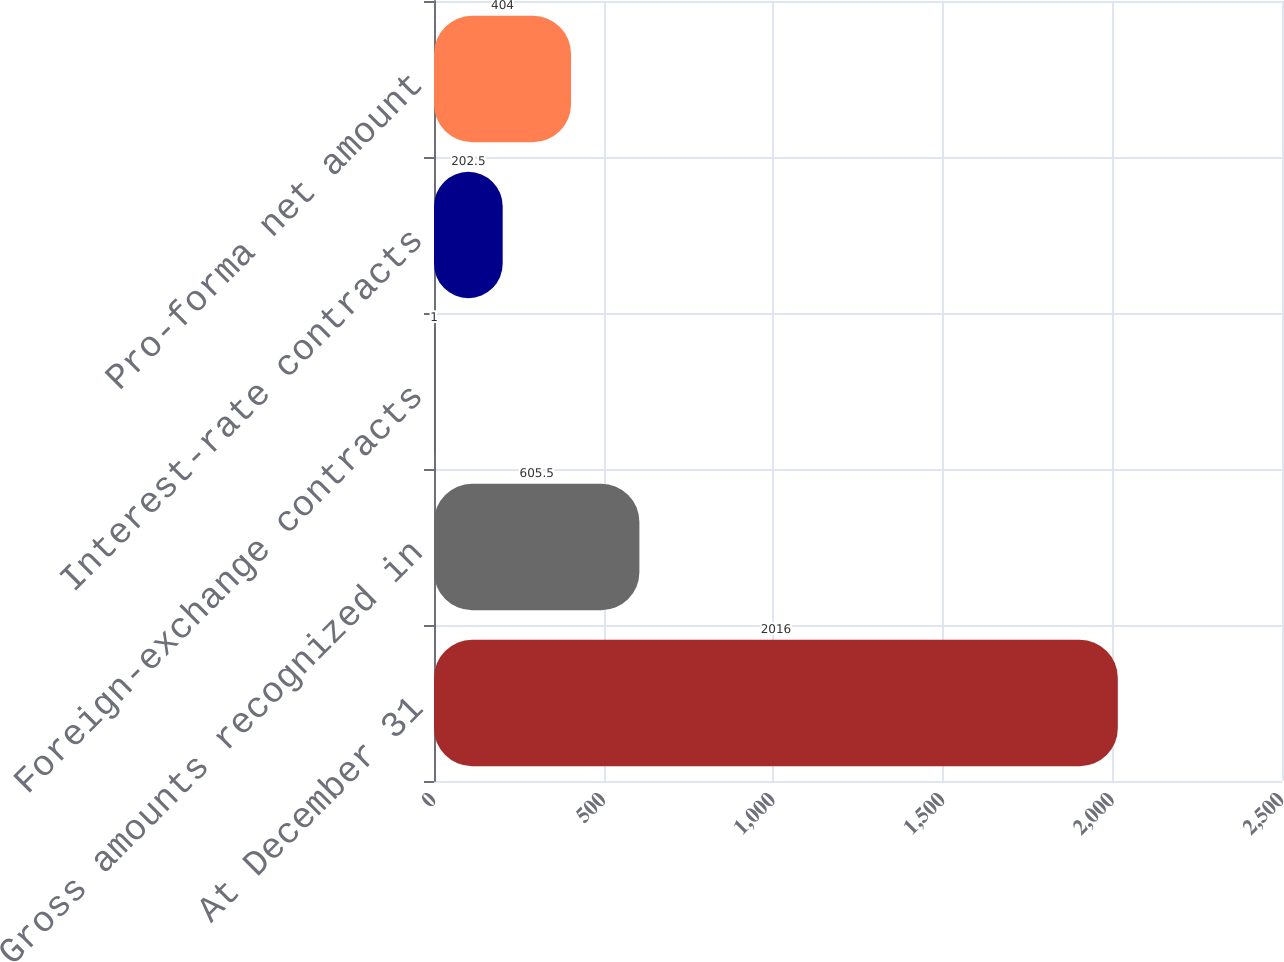Convert chart to OTSL. <chart><loc_0><loc_0><loc_500><loc_500><bar_chart><fcel>At December 31<fcel>Gross amounts recognized in<fcel>Foreign-exchange contracts<fcel>Interest-rate contracts<fcel>Pro-forma net amount<nl><fcel>2016<fcel>605.5<fcel>1<fcel>202.5<fcel>404<nl></chart> 